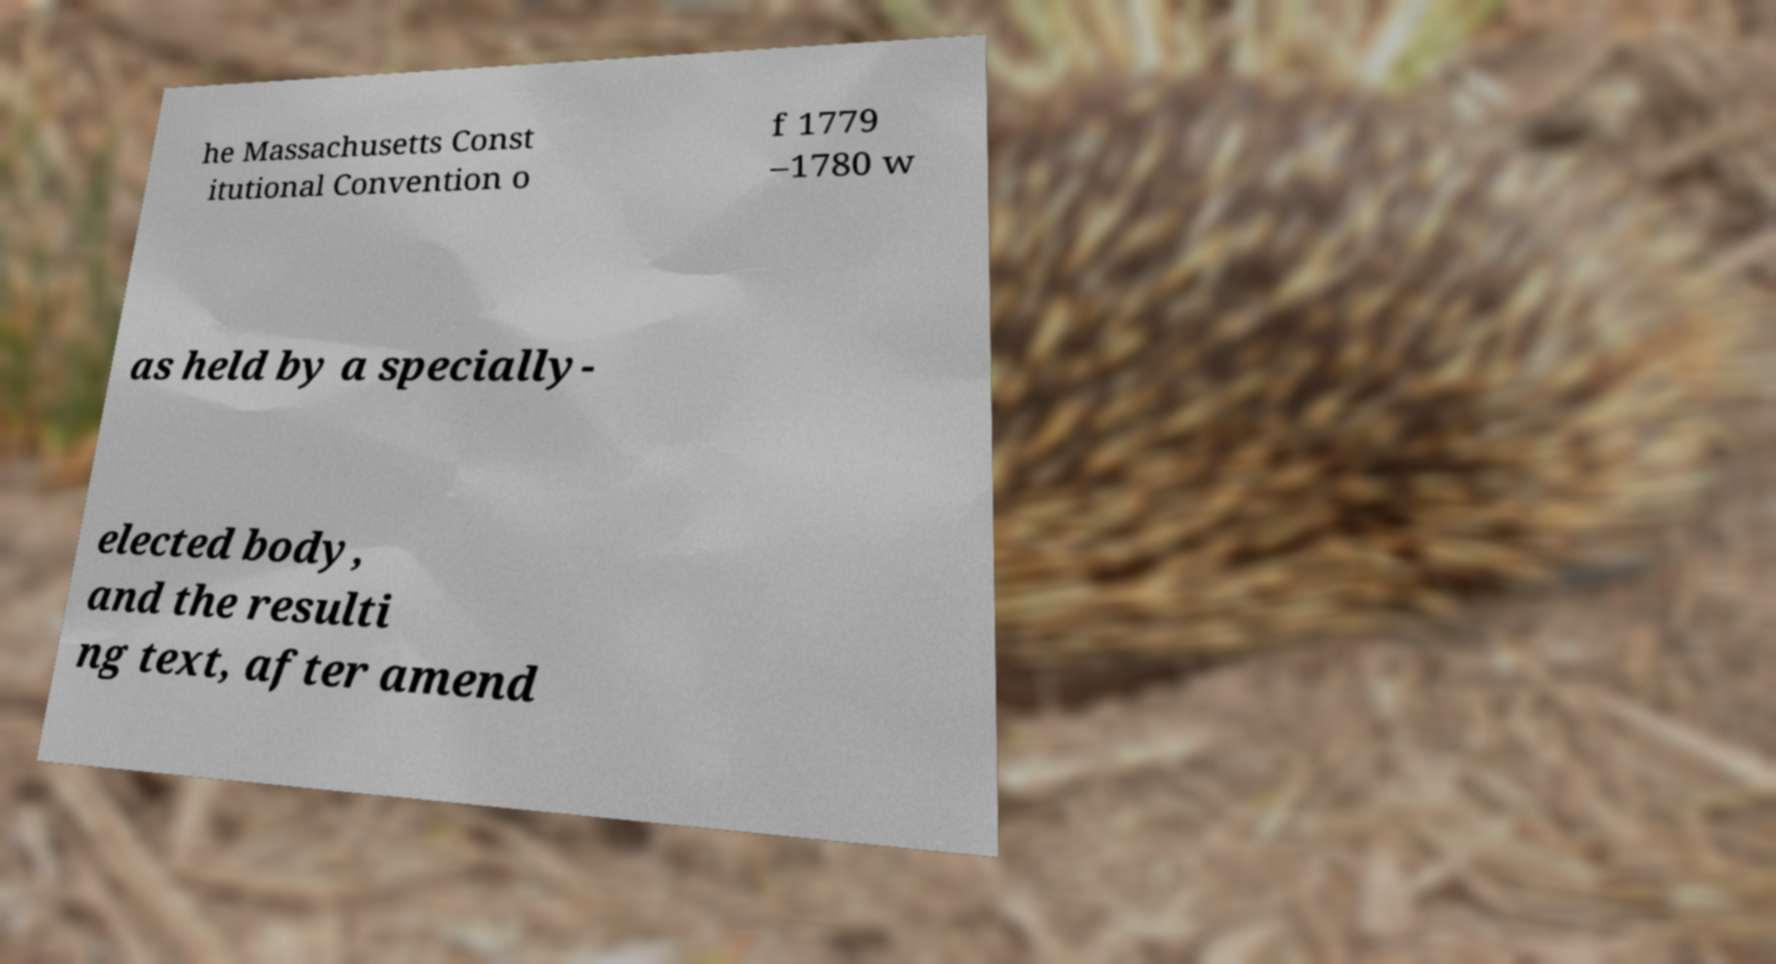Could you extract and type out the text from this image? he Massachusetts Const itutional Convention o f 1779 –1780 w as held by a specially- elected body, and the resulti ng text, after amend 